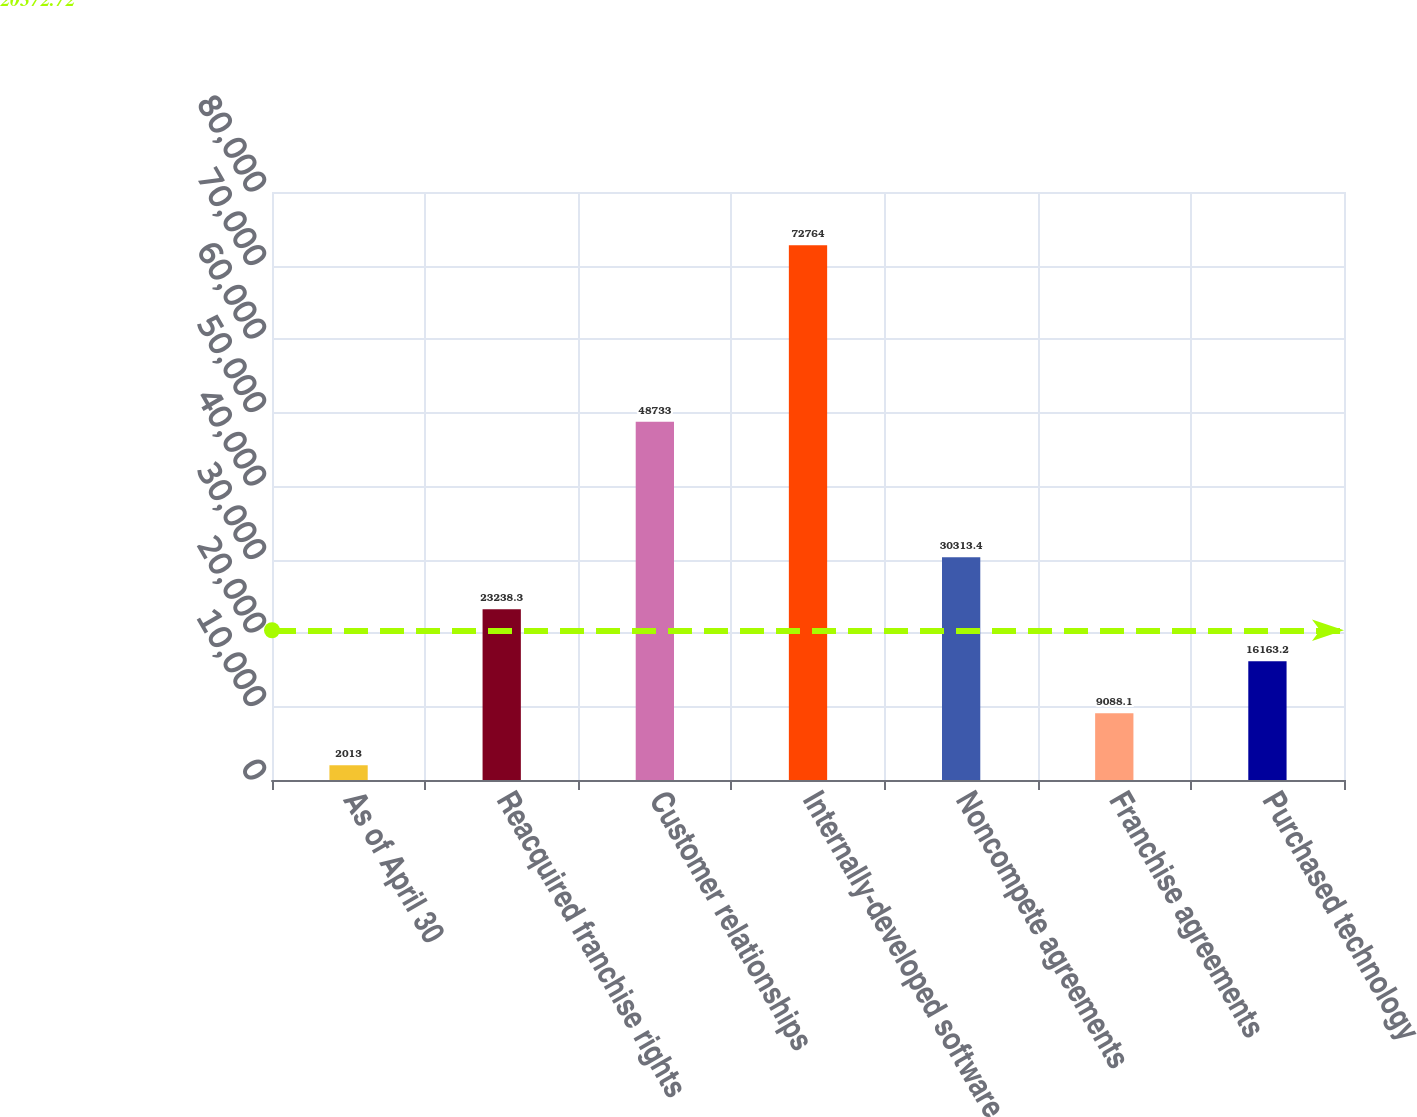<chart> <loc_0><loc_0><loc_500><loc_500><bar_chart><fcel>As of April 30<fcel>Reacquired franchise rights<fcel>Customer relationships<fcel>Internally-developed software<fcel>Noncompete agreements<fcel>Franchise agreements<fcel>Purchased technology<nl><fcel>2013<fcel>23238.3<fcel>48733<fcel>72764<fcel>30313.4<fcel>9088.1<fcel>16163.2<nl></chart> 